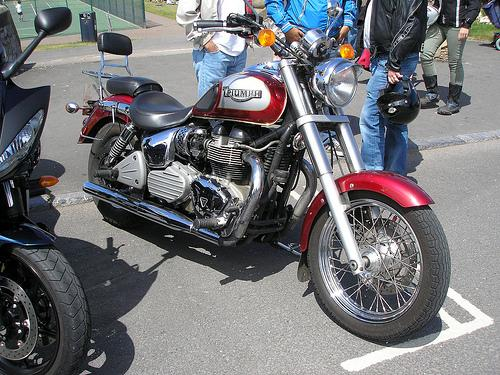What can you tell me about the man wearing blue clothing in this photo? The man wears a blue jacket and has his hands in his pockets. Perform a complex reasoning task by describing the atmosphere of this event or gathering. The atmosphere seems casual and friendly, with people engaged in different activities like playing tennis and observing parked motorcycles, possibly indicating a small, informal motorcycle meetup. Briefly describe the scene involving the motorcycles, including the type of location they are in. Two motorcycles are parked in a parking lot with white lines on the cement, where one has a large front light and a sporty style with black around the headlight. What activities are taking place in this image, and what suggests that it might be a small gathering? There are people playing tennis, and the presence of parked motorcycles suggests it could be a small motorcycle rally. List the number of motorcycles and their colors featured in the image. There are three motorcycles: one red, one black, and another indistinct motorcycle parked next to the red one. Analyze the variations in image quality based on the image provided. The image quality varies across different objects, with some having more detailed bounding box sizes and positions, while others have smaller dimensions with less visual clarity. Explain the possible interactions between the man wearing jeans and the objects around him. The man with jeans might be a motorcycle rider or a spectator, and he possibly interacts with the motorcycles, helmet, or other people present. Are there any visible people in the image, and if so, what clothing items can be identified on them? Yes, there are visible people wearing jeans, boots, a blue jacket, a black leather jacket, and greenish-gray pants. Count the objects that suggest safety measures taken by motorcyclists. There are three safety-related objects: a black motorcycle helmet, a white motorcycle helmet, and a pair of black motorcycle boots. 